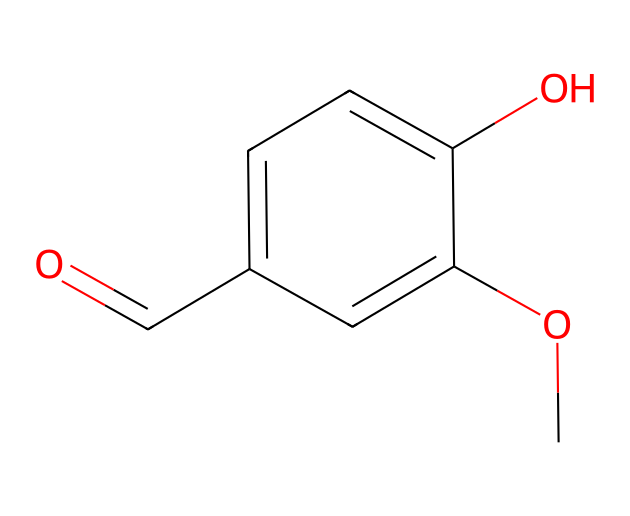What is the molecular formula of vanillin? To determine the molecular formula, we can count the number of each type of atom from the SMILES representation. The representation "COc1cc(C=O)ccc1O" indicates there are 8 carbons (C), 8 hydrogens (H), and 3 oxygens (O). Therefore, the molecular formula is C8H8O3.
Answer: C8H8O3 How many rings are present in the structure of vanillin? The SMILES representation includes "c" characters, indicating aromatic carbon atoms that are part of a ring structure. In this case, the presence of "c" indicates a six-membered aromatic ring, which confirms that only one ring is present in vanillin.
Answer: 1 What functional groups are present in vanillin? By examining the SMILES, we find specific structural indicators: "C=O" indicates a carbonyl group (aldehyde), "O" (attached to "c") indicates a hydroxyl group (alcohol), and "CO" indicates a methoxy group (ether). All three functional groups: aldehyde, hydroxyl, and methoxy are present.
Answer: aldehyde, hydroxyl, methoxy What is the degree of saturation in vanillin? The degree of saturation can be determined by looking at the rings and double bonds in the compound. The presence of one aromatic ring and a carbonyl group implies a total of two areas of unsaturation. As a rule of thumb, each double bond or ring adds one to the degree of saturation. Therefore, vanillin has a degree of saturation of 2.
Answer: 2 Which part of the structure is responsible for the aromatic property of vanillin? The presence of the six-membered carbon ring with alternating double bonds (the "c" characters in the SMILES) indicates that vanillin has an aromatic property. The entire aromatic ring structure facilitates the characteristic aromatic behavior of the compound.
Answer: aromatic ring In what type of chemical class does vanillin belong? Vanillin is classified under both phenols (due to the hydroxyl group on the aromatic ring) and aldehydes (due to the carbonyl group). Thus, it can be referred to as a phenolic compound with an aldehyde functional group, identifying it within the realm of phenols.
Answer: phenolic compound 